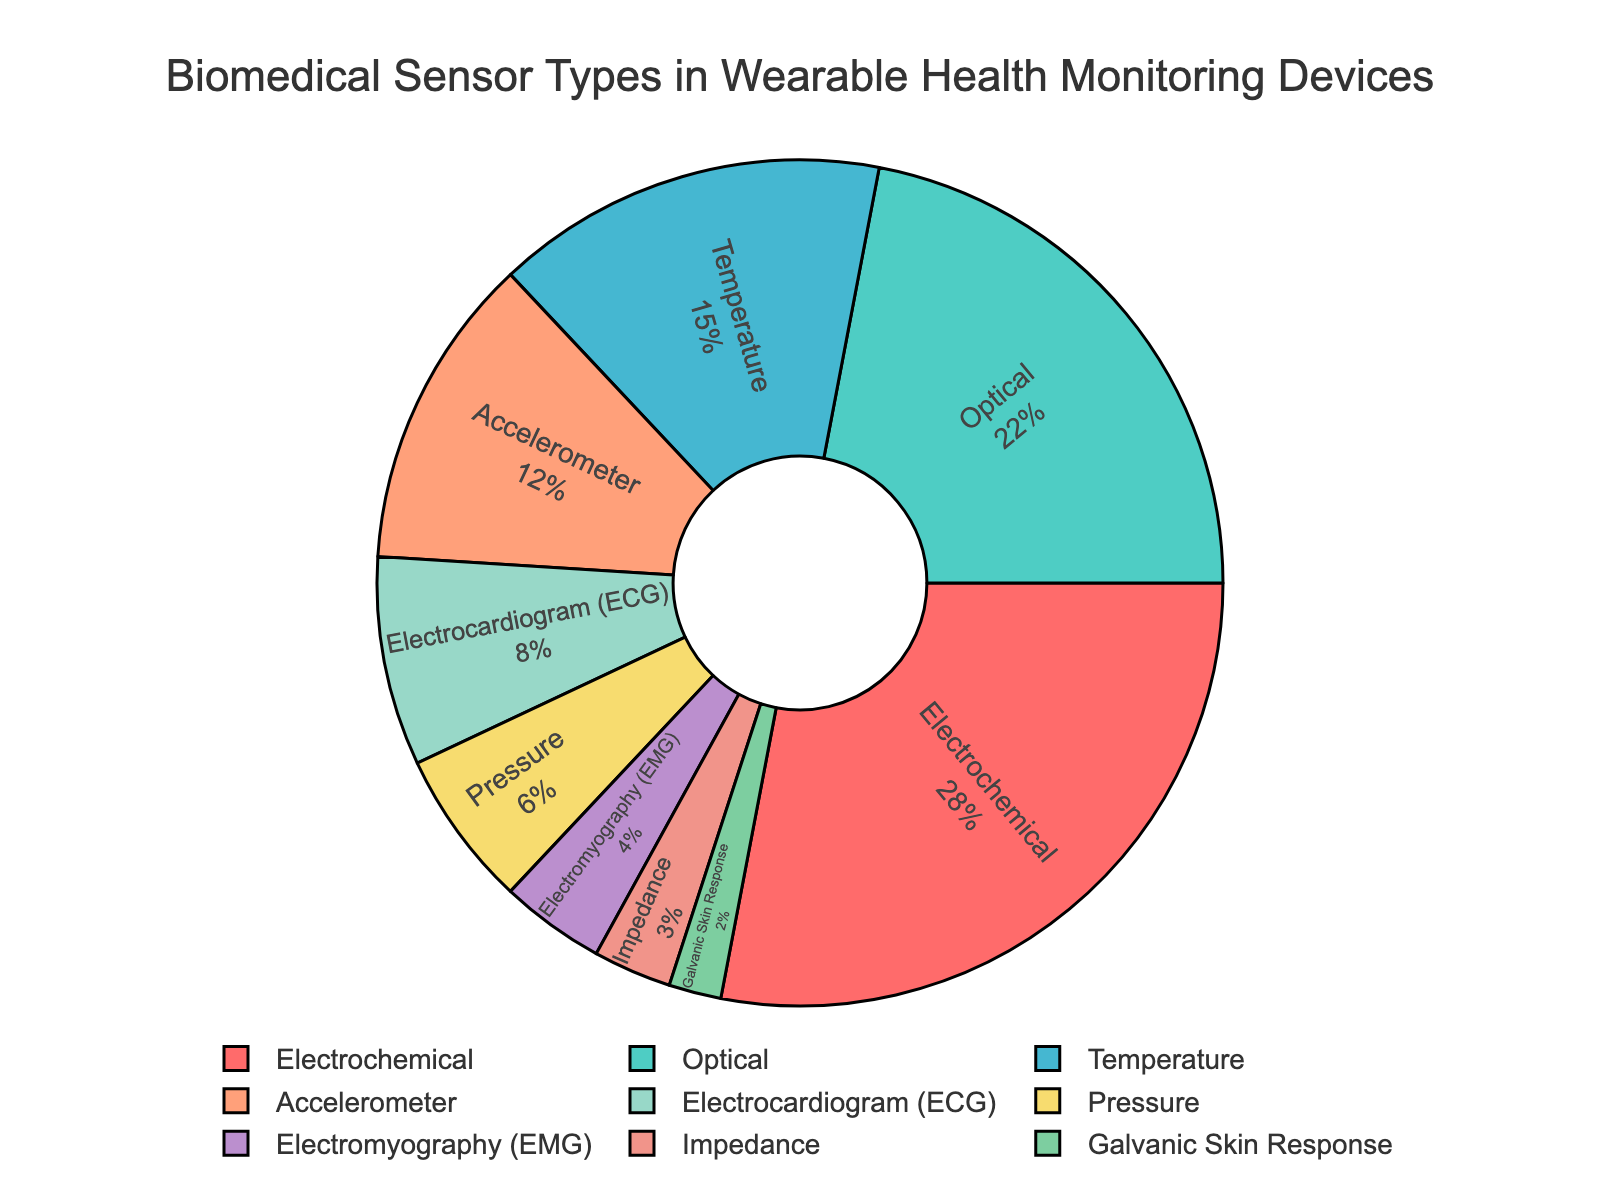Which sensor type has the largest percentage? The pie chart shows the different sensor types along with their percentages. The largest segment is labeled "Electrochemical" with 28%.
Answer: Electrochemical Which two sensor types together make up 50% of the total? Summing up the percentages of the Electrochemical (28%) and Optical (22%) sensors, the total is 28 + 22 = 50%.
Answer: Electrochemical and Optical How many sensor types have a percentage less than 10%? By looking at the pie chart, the sensor types with less than 10% are Electrocardiogram (8%), Pressure (6%), Electromyography (4%), Impedance (3%), and Galvanic Skin Response (2%). This makes a total of 5 sensor types.
Answer: 5 What is the difference in percentage between the Temperature and Accelerometer sensor types? The Temperature sensor type has 15% and the Accelerometer has 12%. The difference is 15 - 12 = 3%.
Answer: 3% Which sensor type has the smallest percentage and what is it? The chart shows the Galvanic Skin Response sensor type with the smallest percentage of 2%.
Answer: Galvanic Skin Response, 2% Are there more sensor types with percentages higher than 10% or lower than 10%? Sensors with more than 10% are Electrochemical (28%), Optical (22%), Temperature (15%), and Accelerometer (12%). This makes 4 sensor types. Sensors with less than 10% are Electrocardiogram (8%), Pressure (6%), Electromyography (4%), Impedance (3%), and Galvanic Skin Response (2%) making a total of 5. Therefore, there are more sensor types with less than 10%.
Answer: Lower than 10% What is the combined percentage of Electrocardiogram and Pressure sensor types? The Electrocardiogram sensor type has 8% and the Pressure sensor type has 6%. The combined percentage is 8 + 6 = 14%.
Answer: 14% Which color represents the Optical sensor type in the chart? On the pie chart, each segment has a distinct color and Optical is labeled with a turquoise-like color.
Answer: Turquoise What is the average percentage of the sensor types with less than 5%? The sensor types with less than 5% are Electromyography (4%), Impedance (3%), and Galvanic Skin Response (2%). Summing these percentages, 4 + 3 + 2 = 9, and then averaging them, 9 / 3 = 3%.
Answer: 3% Which sensor type has the highest percentage that is still below 20%? The chart shows that Optical has 22%, but that's above 20%. The next highest under 20% is Temperature with 15%.
Answer: Temperature, 15% 